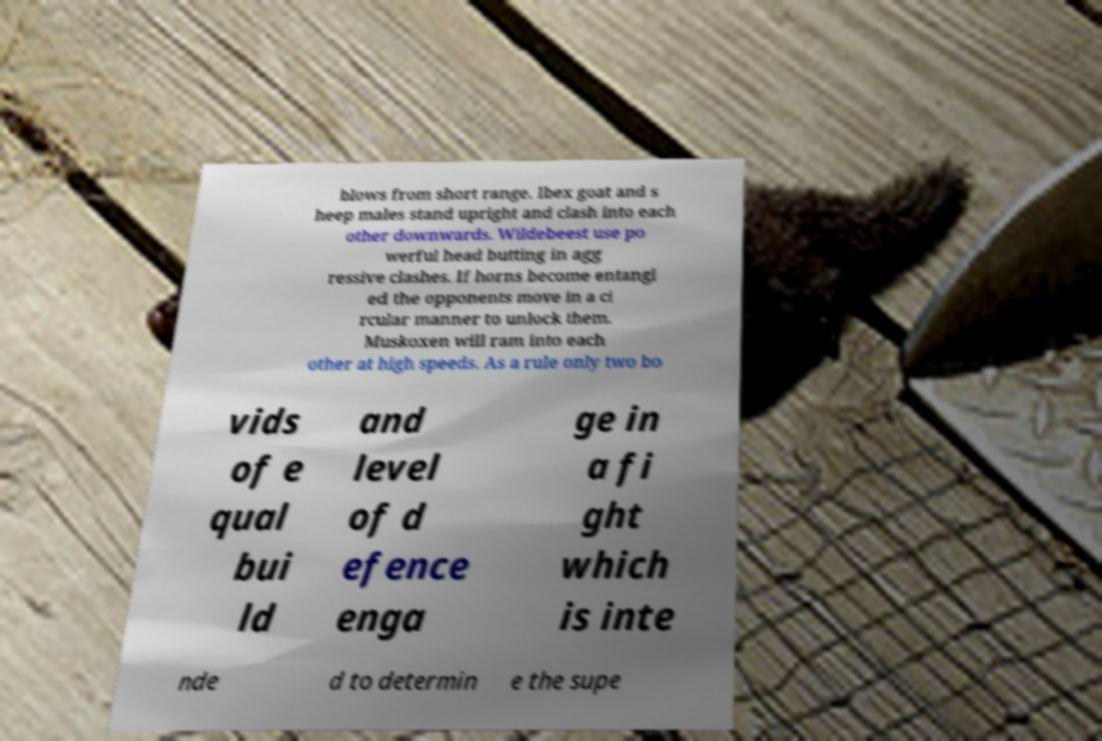For documentation purposes, I need the text within this image transcribed. Could you provide that? blows from short range. Ibex goat and s heep males stand upright and clash into each other downwards. Wildebeest use po werful head butting in agg ressive clashes. If horns become entangl ed the opponents move in a ci rcular manner to unlock them. Muskoxen will ram into each other at high speeds. As a rule only two bo vids of e qual bui ld and level of d efence enga ge in a fi ght which is inte nde d to determin e the supe 